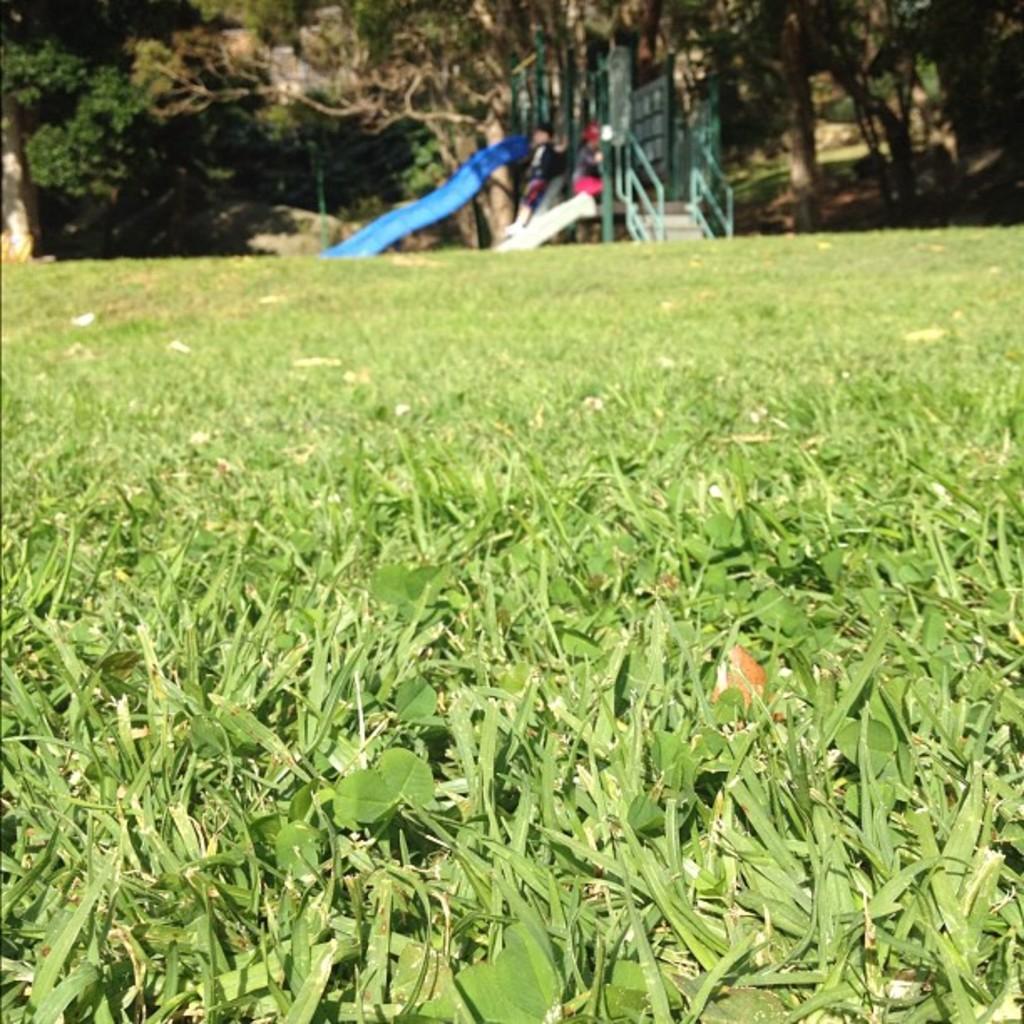In one or two sentences, can you explain what this image depicts? In this image at the bottom there is grass and leaves visible, at the top tree, children's and steps visible. 